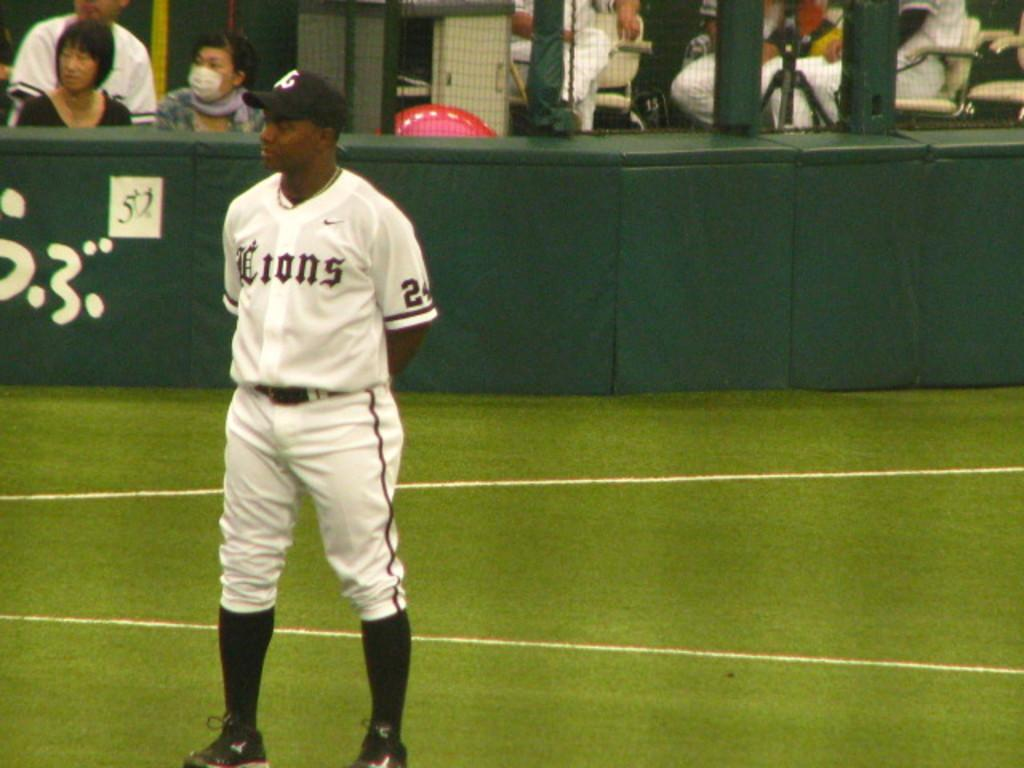<image>
Present a compact description of the photo's key features. A Lions player with the number 24 stands on a baseball field. 